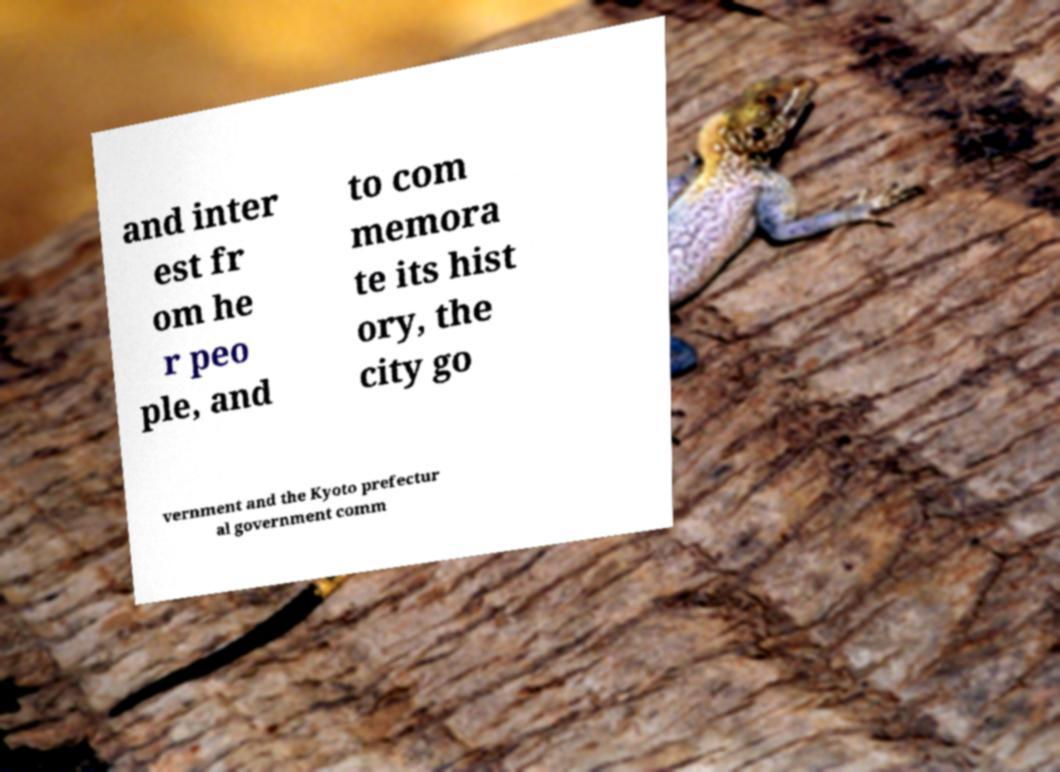Can you read and provide the text displayed in the image?This photo seems to have some interesting text. Can you extract and type it out for me? and inter est fr om he r peo ple, and to com memora te its hist ory, the city go vernment and the Kyoto prefectur al government comm 